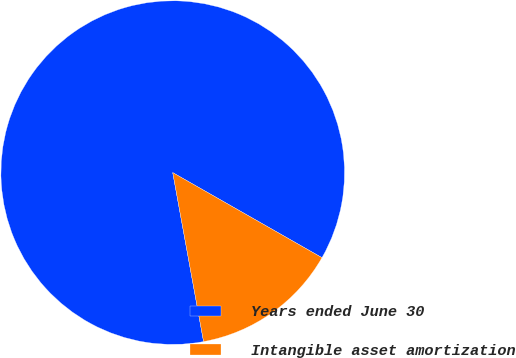<chart> <loc_0><loc_0><loc_500><loc_500><pie_chart><fcel>Years ended June 30<fcel>Intangible asset amortization<nl><fcel>86.12%<fcel>13.88%<nl></chart> 